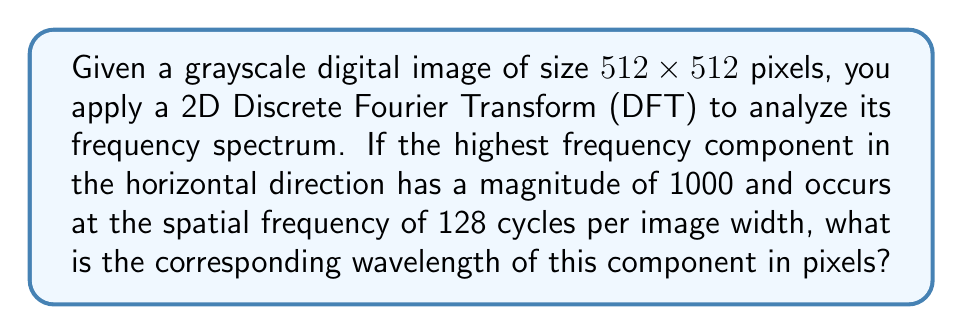Solve this math problem. To solve this problem, we need to understand the relationship between spatial frequency and wavelength in the context of the Discrete Fourier Transform of a digital image.

1. First, let's recall the basics of the 2D DFT:
   - For an NxN image, the DFT produces an NxN frequency spectrum.
   - The frequency components range from 0 to N/2 cycles per image dimension.

2. In this case, we have:
   - Image size: 512x512 pixels
   - Highest frequency component: 128 cycles per image width

3. To find the wavelength, we use the relationship:
   $$ \text{wavelength} = \frac{\text{image width}}{\text{frequency (cycles per image width)}} $$

4. Substituting the values:
   $$ \text{wavelength} = \frac{512 \text{ pixels}}{128 \text{ cycles}} $$

5. Simplifying:
   $$ \text{wavelength} = 4 \text{ pixels} $$

This result means that the highest frequency component completes one full cycle every 4 pixels in the horizontal direction of the original image.
Answer: 4 pixels 